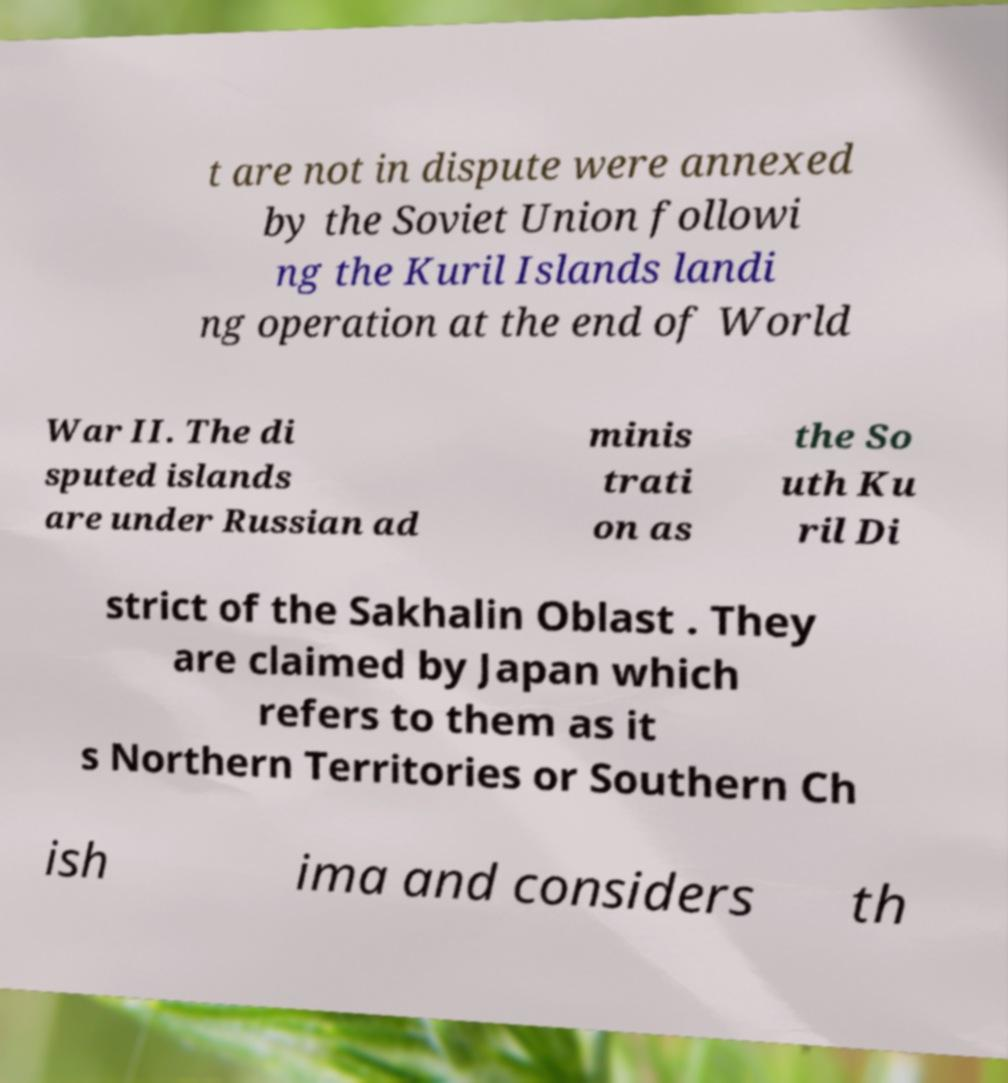Please read and relay the text visible in this image. What does it say? t are not in dispute were annexed by the Soviet Union followi ng the Kuril Islands landi ng operation at the end of World War II. The di sputed islands are under Russian ad minis trati on as the So uth Ku ril Di strict of the Sakhalin Oblast . They are claimed by Japan which refers to them as it s Northern Territories or Southern Ch ish ima and considers th 